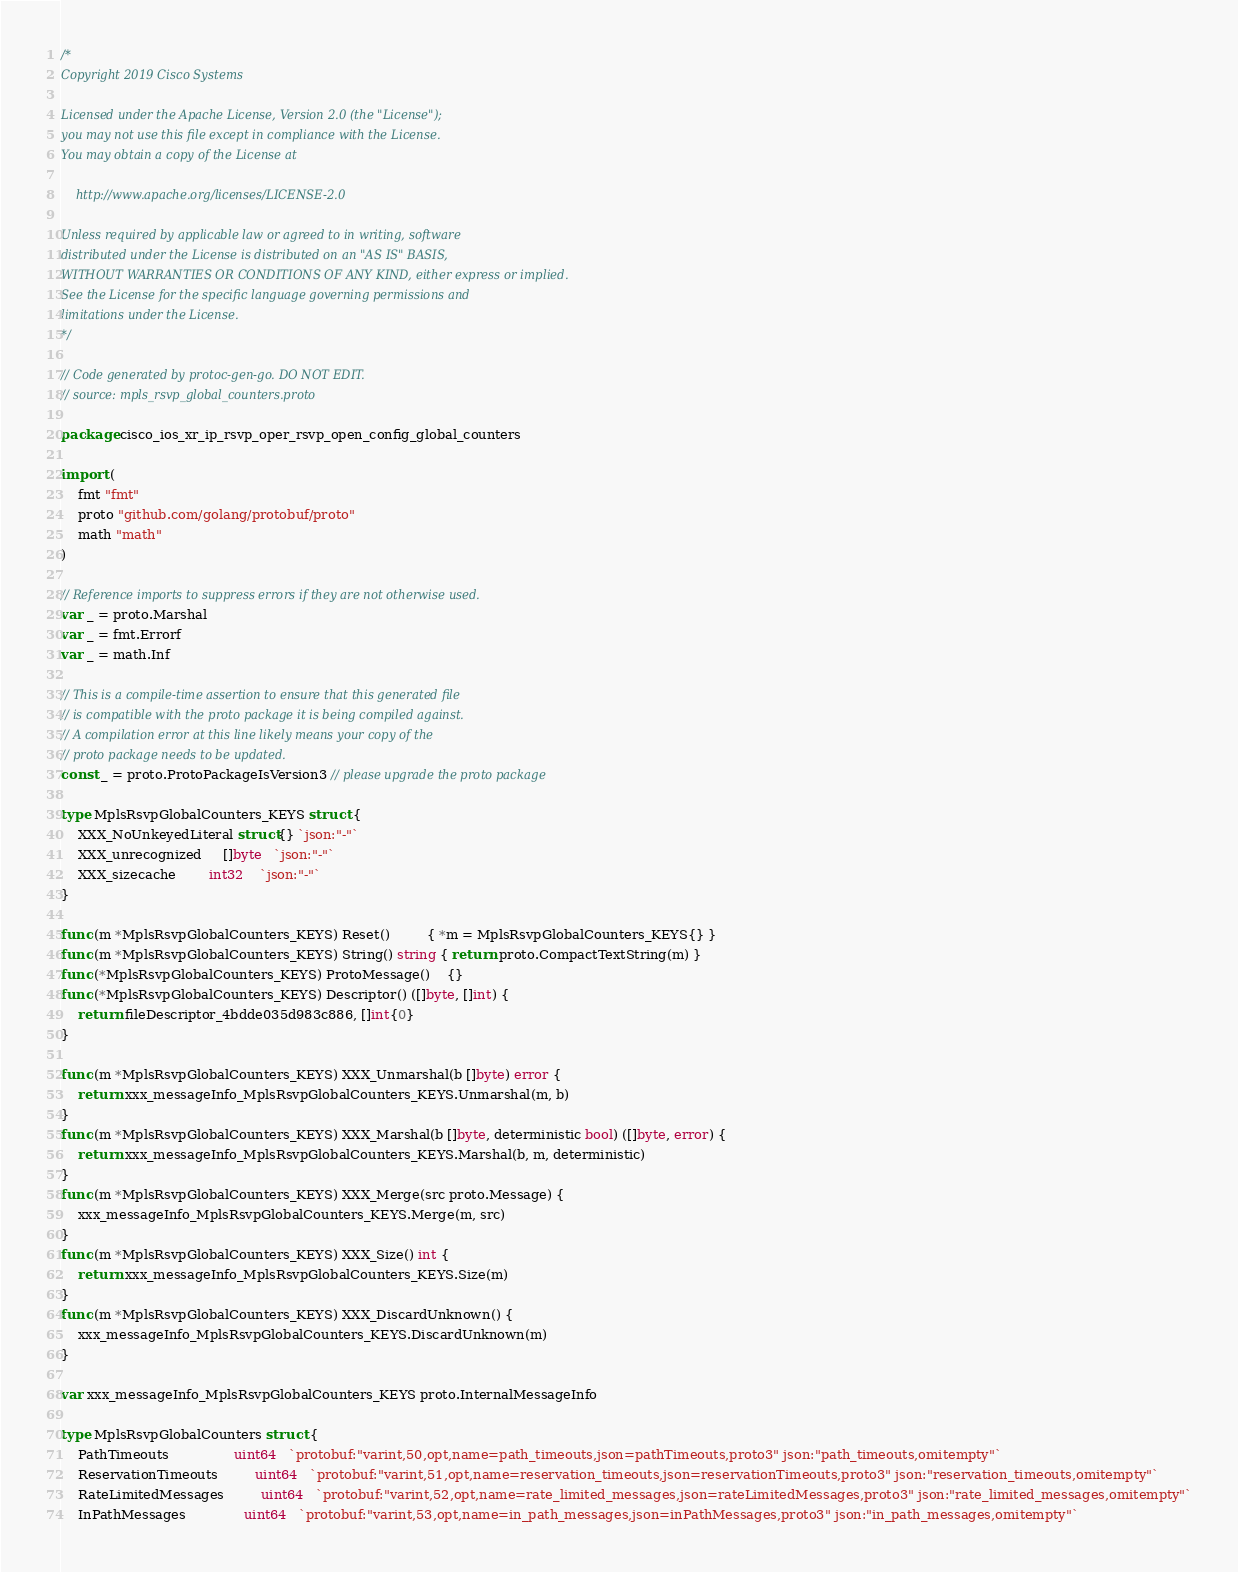<code> <loc_0><loc_0><loc_500><loc_500><_Go_>/*
Copyright 2019 Cisco Systems

Licensed under the Apache License, Version 2.0 (the "License");
you may not use this file except in compliance with the License.
You may obtain a copy of the License at

    http://www.apache.org/licenses/LICENSE-2.0

Unless required by applicable law or agreed to in writing, software
distributed under the License is distributed on an "AS IS" BASIS,
WITHOUT WARRANTIES OR CONDITIONS OF ANY KIND, either express or implied.
See the License for the specific language governing permissions and
limitations under the License.
*/

// Code generated by protoc-gen-go. DO NOT EDIT.
// source: mpls_rsvp_global_counters.proto

package cisco_ios_xr_ip_rsvp_oper_rsvp_open_config_global_counters

import (
	fmt "fmt"
	proto "github.com/golang/protobuf/proto"
	math "math"
)

// Reference imports to suppress errors if they are not otherwise used.
var _ = proto.Marshal
var _ = fmt.Errorf
var _ = math.Inf

// This is a compile-time assertion to ensure that this generated file
// is compatible with the proto package it is being compiled against.
// A compilation error at this line likely means your copy of the
// proto package needs to be updated.
const _ = proto.ProtoPackageIsVersion3 // please upgrade the proto package

type MplsRsvpGlobalCounters_KEYS struct {
	XXX_NoUnkeyedLiteral struct{} `json:"-"`
	XXX_unrecognized     []byte   `json:"-"`
	XXX_sizecache        int32    `json:"-"`
}

func (m *MplsRsvpGlobalCounters_KEYS) Reset()         { *m = MplsRsvpGlobalCounters_KEYS{} }
func (m *MplsRsvpGlobalCounters_KEYS) String() string { return proto.CompactTextString(m) }
func (*MplsRsvpGlobalCounters_KEYS) ProtoMessage()    {}
func (*MplsRsvpGlobalCounters_KEYS) Descriptor() ([]byte, []int) {
	return fileDescriptor_4bdde035d983c886, []int{0}
}

func (m *MplsRsvpGlobalCounters_KEYS) XXX_Unmarshal(b []byte) error {
	return xxx_messageInfo_MplsRsvpGlobalCounters_KEYS.Unmarshal(m, b)
}
func (m *MplsRsvpGlobalCounters_KEYS) XXX_Marshal(b []byte, deterministic bool) ([]byte, error) {
	return xxx_messageInfo_MplsRsvpGlobalCounters_KEYS.Marshal(b, m, deterministic)
}
func (m *MplsRsvpGlobalCounters_KEYS) XXX_Merge(src proto.Message) {
	xxx_messageInfo_MplsRsvpGlobalCounters_KEYS.Merge(m, src)
}
func (m *MplsRsvpGlobalCounters_KEYS) XXX_Size() int {
	return xxx_messageInfo_MplsRsvpGlobalCounters_KEYS.Size(m)
}
func (m *MplsRsvpGlobalCounters_KEYS) XXX_DiscardUnknown() {
	xxx_messageInfo_MplsRsvpGlobalCounters_KEYS.DiscardUnknown(m)
}

var xxx_messageInfo_MplsRsvpGlobalCounters_KEYS proto.InternalMessageInfo

type MplsRsvpGlobalCounters struct {
	PathTimeouts                uint64   `protobuf:"varint,50,opt,name=path_timeouts,json=pathTimeouts,proto3" json:"path_timeouts,omitempty"`
	ReservationTimeouts         uint64   `protobuf:"varint,51,opt,name=reservation_timeouts,json=reservationTimeouts,proto3" json:"reservation_timeouts,omitempty"`
	RateLimitedMessages         uint64   `protobuf:"varint,52,opt,name=rate_limited_messages,json=rateLimitedMessages,proto3" json:"rate_limited_messages,omitempty"`
	InPathMessages              uint64   `protobuf:"varint,53,opt,name=in_path_messages,json=inPathMessages,proto3" json:"in_path_messages,omitempty"`</code> 